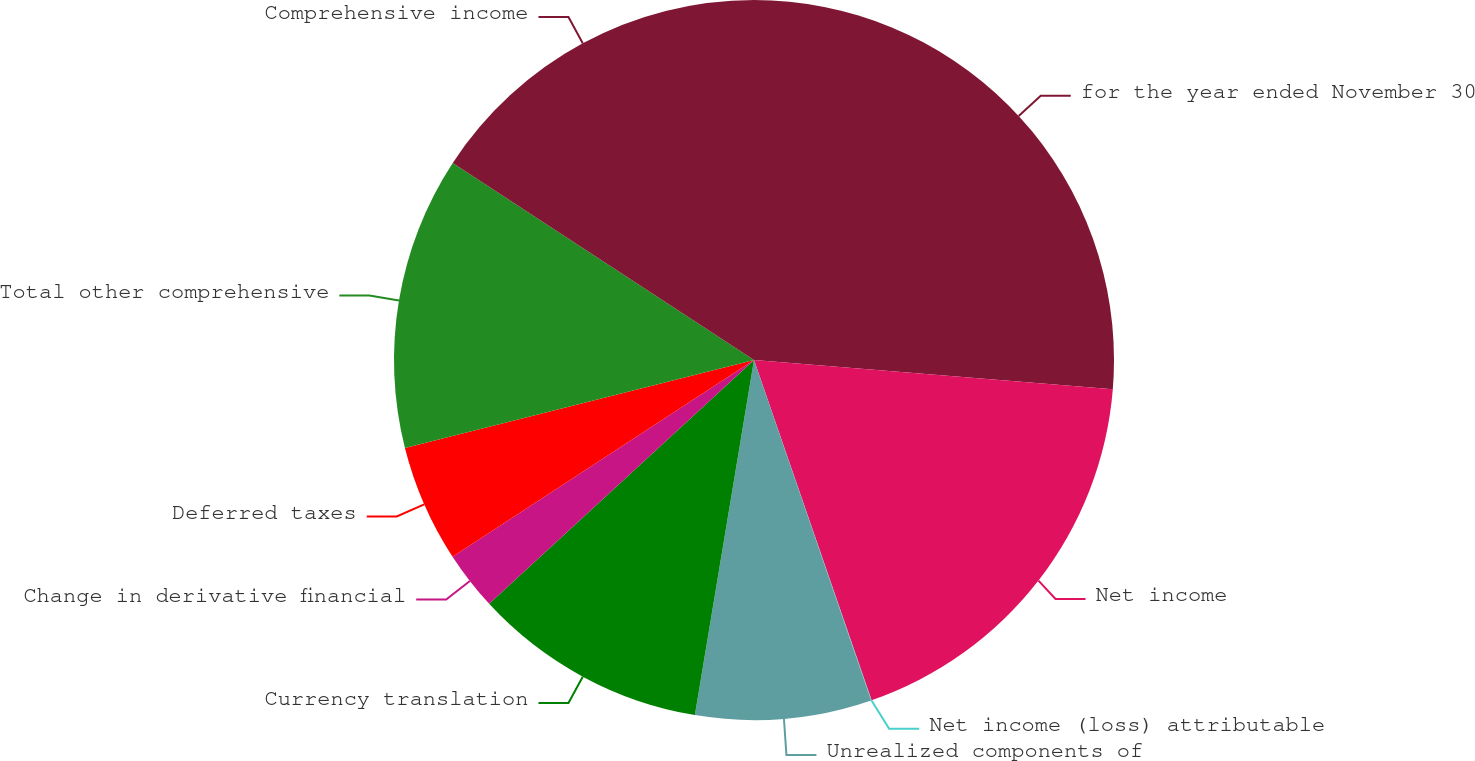Convert chart. <chart><loc_0><loc_0><loc_500><loc_500><pie_chart><fcel>for the year ended November 30<fcel>Net income<fcel>Net income (loss) attributable<fcel>Unrealized components of<fcel>Currency translation<fcel>Change in derivative financial<fcel>Deferred taxes<fcel>Total other comprehensive<fcel>Comprehensive income<nl><fcel>26.29%<fcel>18.41%<fcel>0.02%<fcel>7.9%<fcel>10.53%<fcel>2.64%<fcel>5.27%<fcel>13.15%<fcel>15.78%<nl></chart> 